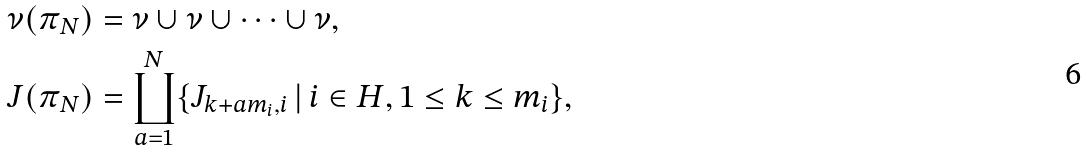<formula> <loc_0><loc_0><loc_500><loc_500>\nu ( \pi _ { N } ) & = \nu \cup \nu \cup \cdots \cup \nu , \\ J ( \pi _ { N } ) & = \coprod _ { a = 1 } ^ { N } \{ J _ { k + a m _ { i } , i } \, | \, i \in H , 1 \leq k \leq m _ { i } \} ,</formula> 